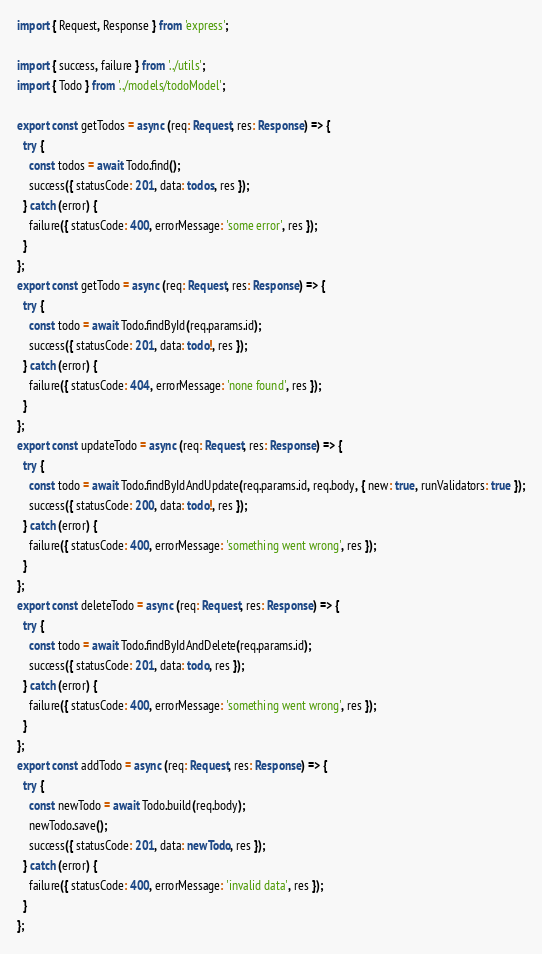<code> <loc_0><loc_0><loc_500><loc_500><_TypeScript_>import { Request, Response } from 'express';

import { success, failure } from '../utils';
import { Todo } from '../models/todoModel';

export const getTodos = async (req: Request, res: Response) => {
  try {
    const todos = await Todo.find();
    success({ statusCode: 201, data: todos, res });
  } catch (error) {
    failure({ statusCode: 400, errorMessage: 'some error', res });
  }
};
export const getTodo = async (req: Request, res: Response) => {
  try {
    const todo = await Todo.findById(req.params.id);
    success({ statusCode: 201, data: todo!, res });
  } catch (error) {
    failure({ statusCode: 404, errorMessage: 'none found', res });
  }
};
export const updateTodo = async (req: Request, res: Response) => {
  try {
    const todo = await Todo.findByIdAndUpdate(req.params.id, req.body, { new: true, runValidators: true });
    success({ statusCode: 200, data: todo!, res });
  } catch (error) {
    failure({ statusCode: 400, errorMessage: 'something went wrong', res });
  }
};
export const deleteTodo = async (req: Request, res: Response) => {
  try {
    const todo = await Todo.findByIdAndDelete(req.params.id);
    success({ statusCode: 201, data: todo, res });
  } catch (error) {
    failure({ statusCode: 400, errorMessage: 'something went wrong', res });
  }
};
export const addTodo = async (req: Request, res: Response) => {
  try {
    const newTodo = await Todo.build(req.body);
    newTodo.save();
    success({ statusCode: 201, data: newTodo, res });
  } catch (error) {
    failure({ statusCode: 400, errorMessage: 'invalid data', res });
  }
};
</code> 